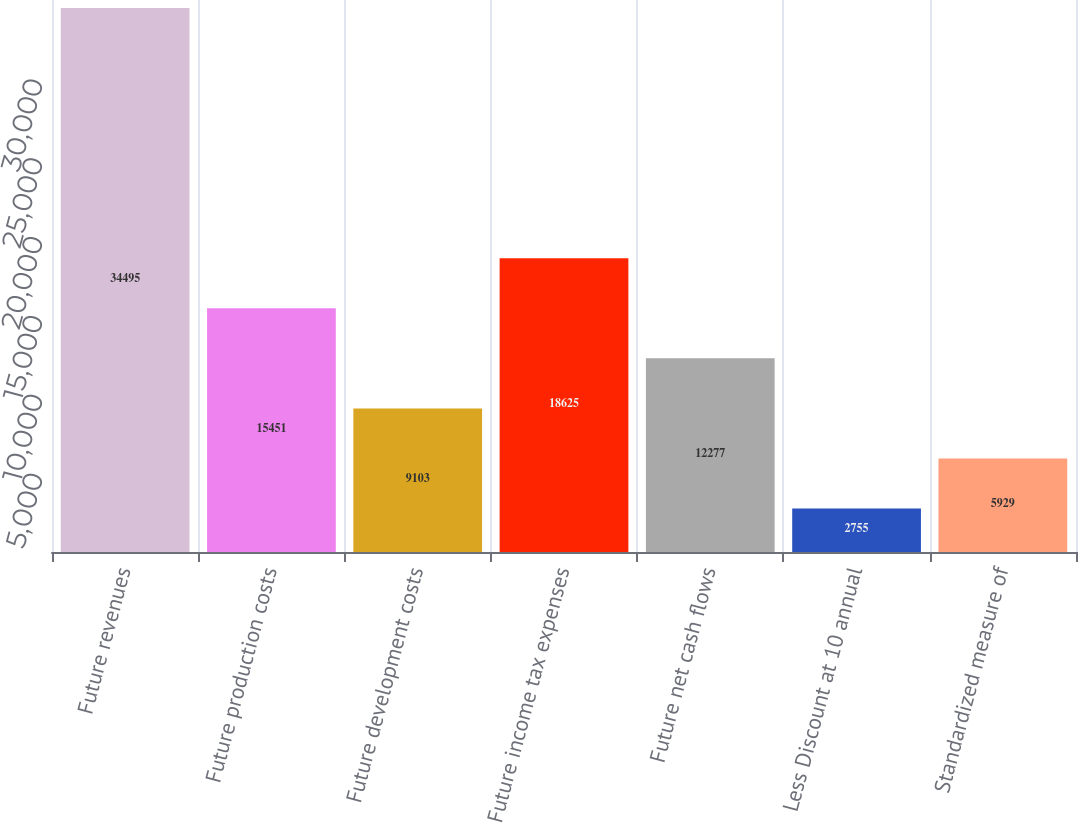<chart> <loc_0><loc_0><loc_500><loc_500><bar_chart><fcel>Future revenues<fcel>Future production costs<fcel>Future development costs<fcel>Future income tax expenses<fcel>Future net cash flows<fcel>Less Discount at 10 annual<fcel>Standardized measure of<nl><fcel>34495<fcel>15451<fcel>9103<fcel>18625<fcel>12277<fcel>2755<fcel>5929<nl></chart> 